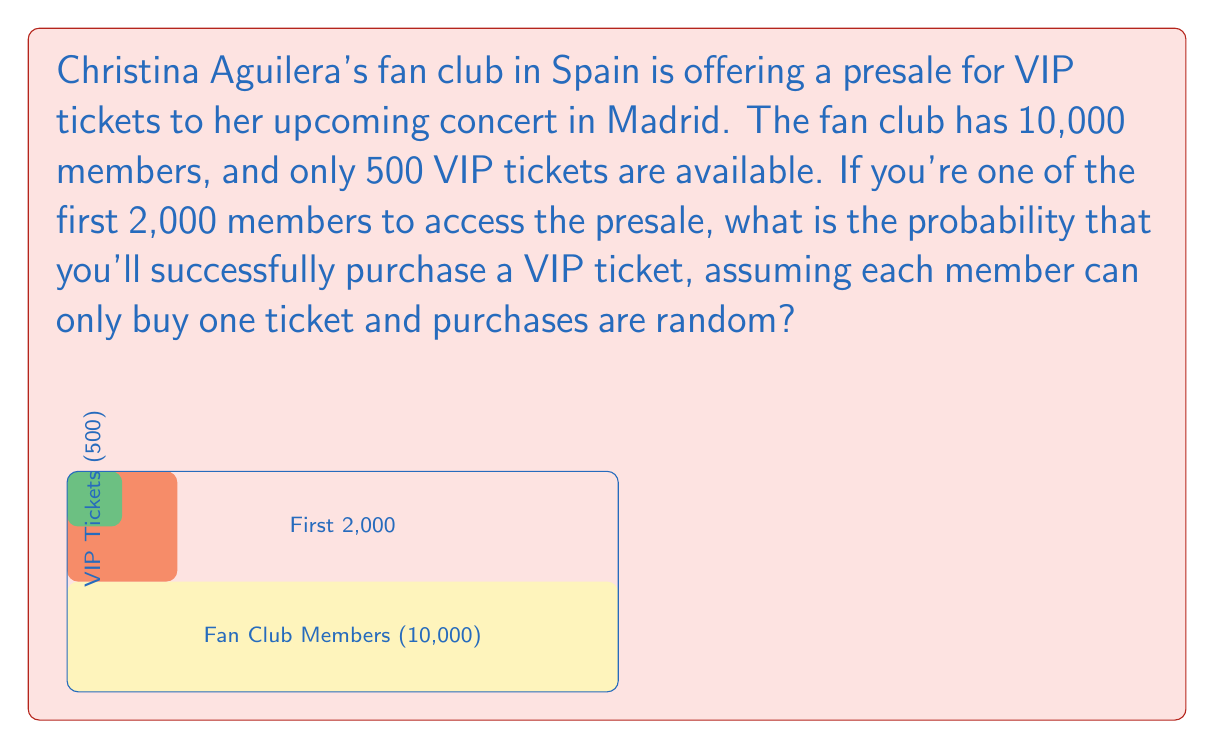Teach me how to tackle this problem. Let's approach this step-by-step:

1) First, we need to understand what the question is asking. We're looking for the probability of getting a VIP ticket, given that we're one of the first 2,000 members to access the presale.

2) The total number of VIP tickets available is 500.

3) The number of people competing for these tickets is 2,000 (the first 2,000 members to access the presale).

4) This scenario follows a hypergeometric distribution, where we're selecting without replacement from a finite population.

5) The probability is calculated as:

   $$P(\text{getting a VIP ticket}) = \frac{\text{number of favorable outcomes}}{\text{total number of possible outcomes}}$$

6) In this case:
   - Favorable outcomes: 500 (the number of VIP tickets)
   - Total possible outcomes: 2,000 (the number of people accessing the presale)

7) Therefore, the probability is:

   $$P(\text{getting a VIP ticket}) = \frac{500}{2000} = \frac{1}{4} = 0.25$$

8) We can also express this as a percentage: 0.25 * 100% = 25%

This means that if you're one of the first 2,000 members to access the presale, you have a 25% chance of successfully purchasing a VIP ticket.
Answer: $\frac{1}{4}$ or 0.25 or 25% 